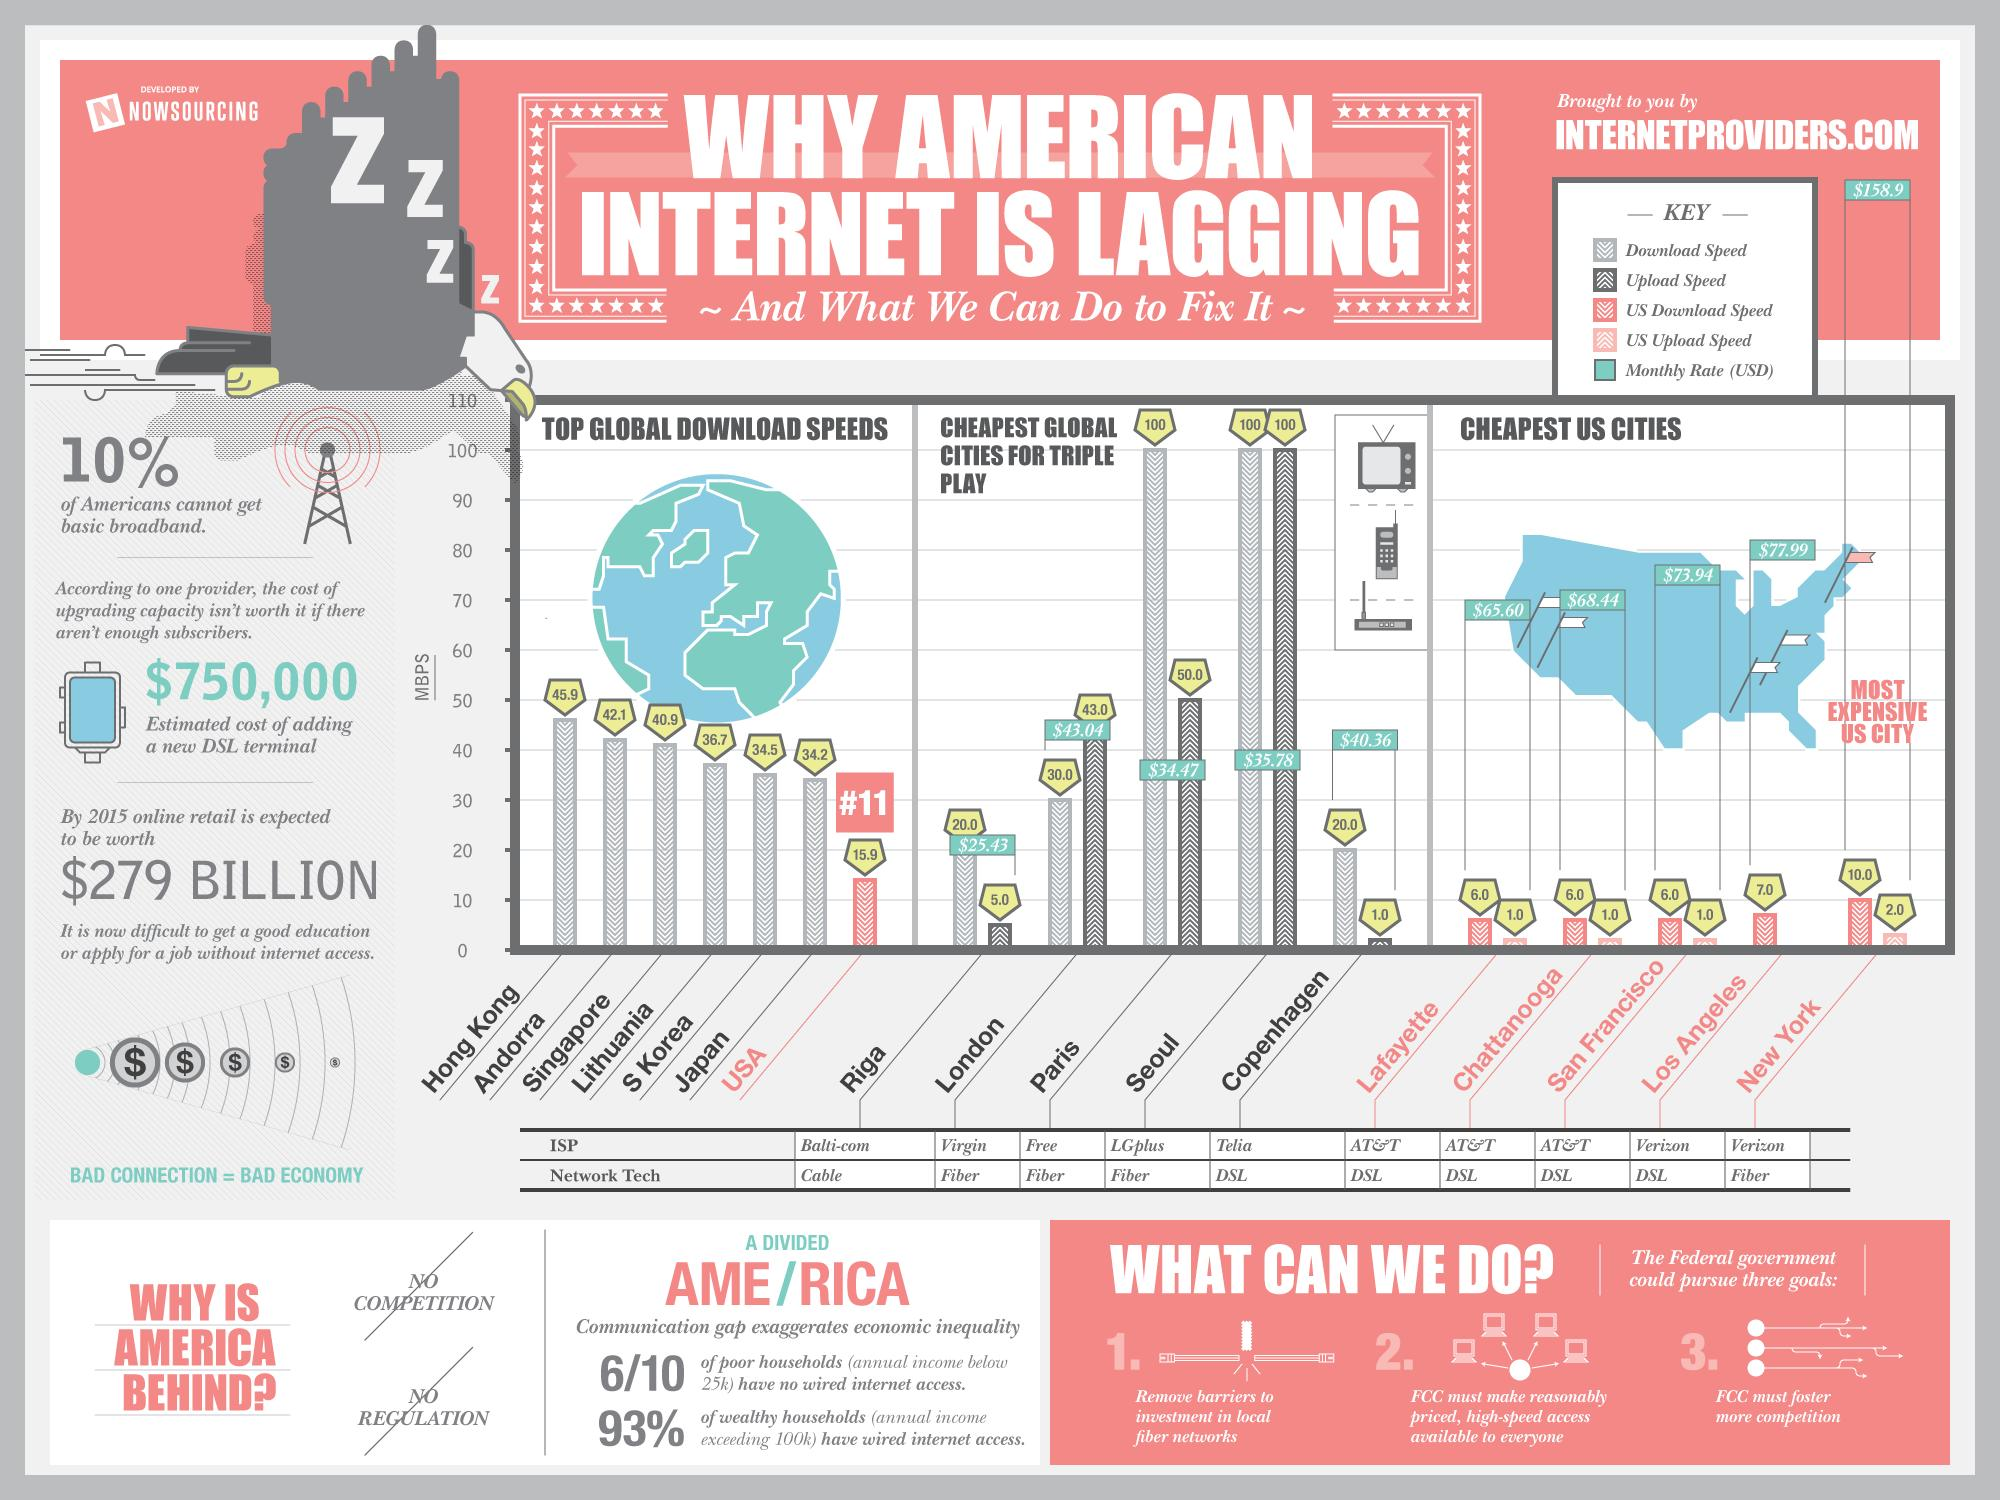Specify some key components in this picture. The monthly internet rate in London, a global city, is 43.04 US Dollars. Paris, a global city, demonstrates a download speed that is two times greater than its upload speed. The United States ranks 11th in the world in terms of top global download speeds. As of the current month, the monthly internet rate in New York City is $158.90. The monthly internet rate in Chattanooga is $68.44. 